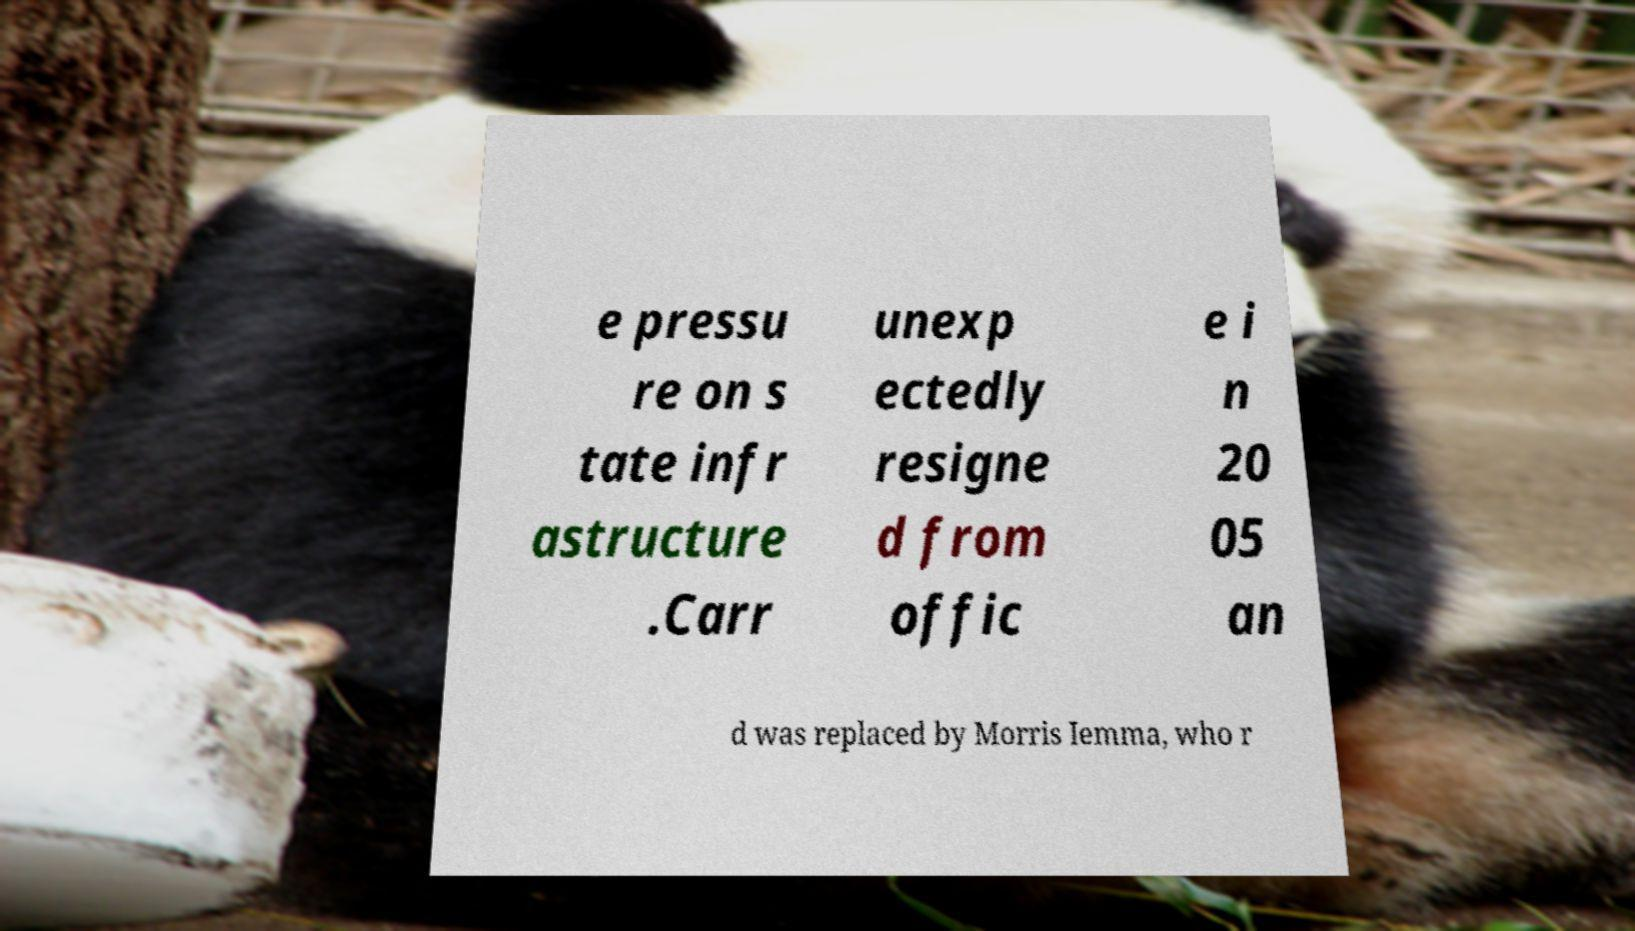Can you read and provide the text displayed in the image?This photo seems to have some interesting text. Can you extract and type it out for me? e pressu re on s tate infr astructure .Carr unexp ectedly resigne d from offic e i n 20 05 an d was replaced by Morris Iemma, who r 